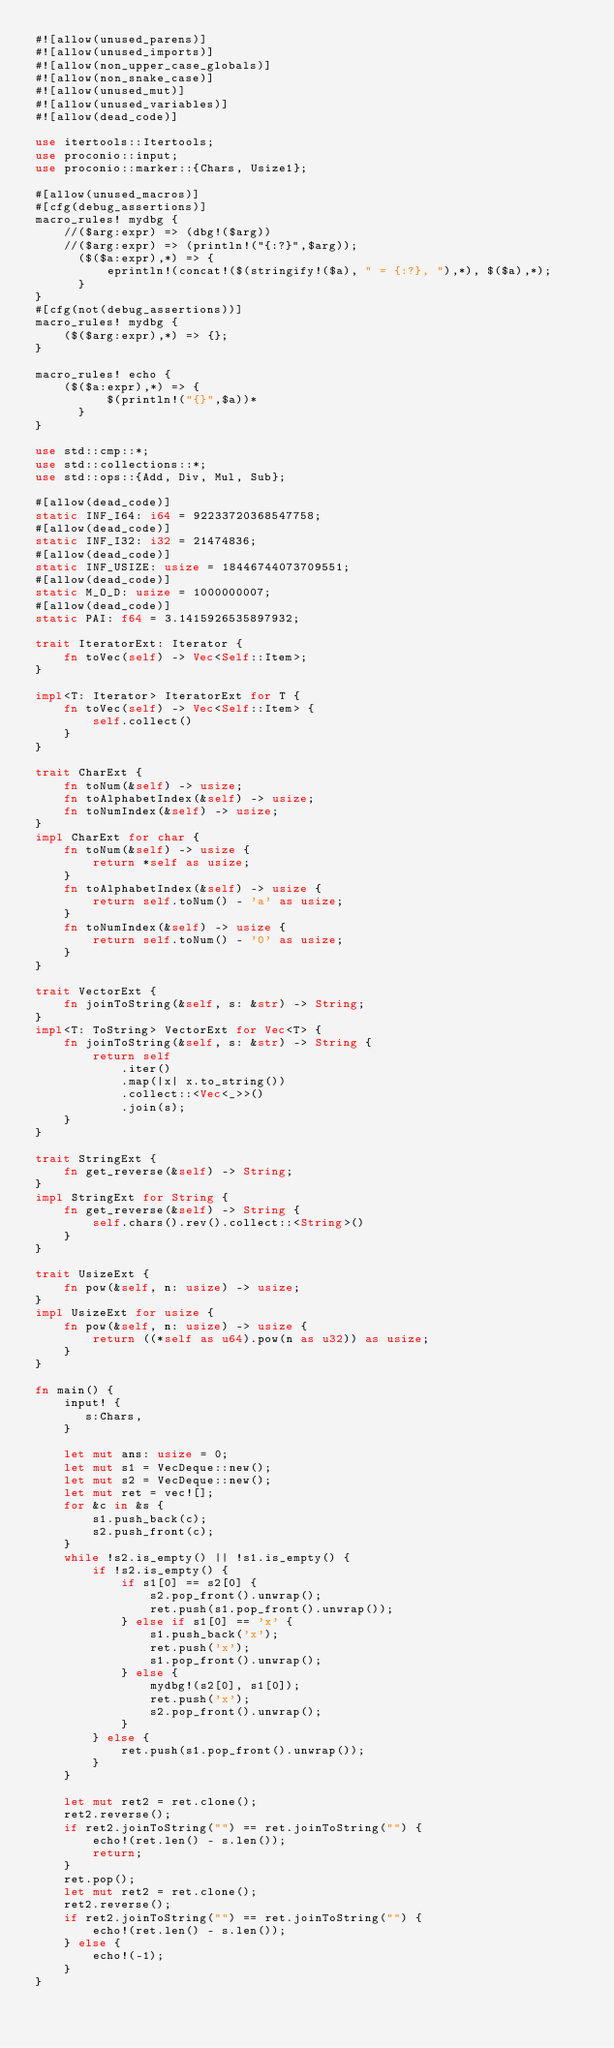<code> <loc_0><loc_0><loc_500><loc_500><_Rust_>#![allow(unused_parens)]
#![allow(unused_imports)]
#![allow(non_upper_case_globals)]
#![allow(non_snake_case)]
#![allow(unused_mut)]
#![allow(unused_variables)]
#![allow(dead_code)]

use itertools::Itertools;
use proconio::input;
use proconio::marker::{Chars, Usize1};

#[allow(unused_macros)]
#[cfg(debug_assertions)]
macro_rules! mydbg {
    //($arg:expr) => (dbg!($arg))
    //($arg:expr) => (println!("{:?}",$arg));
      ($($a:expr),*) => {
          eprintln!(concat!($(stringify!($a), " = {:?}, "),*), $($a),*);
      }
}
#[cfg(not(debug_assertions))]
macro_rules! mydbg {
    ($($arg:expr),*) => {};
}

macro_rules! echo {
    ($($a:expr),*) => {
          $(println!("{}",$a))*
      }
}

use std::cmp::*;
use std::collections::*;
use std::ops::{Add, Div, Mul, Sub};

#[allow(dead_code)]
static INF_I64: i64 = 92233720368547758;
#[allow(dead_code)]
static INF_I32: i32 = 21474836;
#[allow(dead_code)]
static INF_USIZE: usize = 18446744073709551;
#[allow(dead_code)]
static M_O_D: usize = 1000000007;
#[allow(dead_code)]
static PAI: f64 = 3.1415926535897932;

trait IteratorExt: Iterator {
    fn toVec(self) -> Vec<Self::Item>;
}

impl<T: Iterator> IteratorExt for T {
    fn toVec(self) -> Vec<Self::Item> {
        self.collect()
    }
}

trait CharExt {
    fn toNum(&self) -> usize;
    fn toAlphabetIndex(&self) -> usize;
    fn toNumIndex(&self) -> usize;
}
impl CharExt for char {
    fn toNum(&self) -> usize {
        return *self as usize;
    }
    fn toAlphabetIndex(&self) -> usize {
        return self.toNum() - 'a' as usize;
    }
    fn toNumIndex(&self) -> usize {
        return self.toNum() - '0' as usize;
    }
}

trait VectorExt {
    fn joinToString(&self, s: &str) -> String;
}
impl<T: ToString> VectorExt for Vec<T> {
    fn joinToString(&self, s: &str) -> String {
        return self
            .iter()
            .map(|x| x.to_string())
            .collect::<Vec<_>>()
            .join(s);
    }
}

trait StringExt {
    fn get_reverse(&self) -> String;
}
impl StringExt for String {
    fn get_reverse(&self) -> String {
        self.chars().rev().collect::<String>()
    }
}

trait UsizeExt {
    fn pow(&self, n: usize) -> usize;
}
impl UsizeExt for usize {
    fn pow(&self, n: usize) -> usize {
        return ((*self as u64).pow(n as u32)) as usize;
    }
}

fn main() {
    input! {
       s:Chars,
    }

    let mut ans: usize = 0;
    let mut s1 = VecDeque::new();
    let mut s2 = VecDeque::new();
    let mut ret = vec![];
    for &c in &s {
        s1.push_back(c);
        s2.push_front(c);
    }
    while !s2.is_empty() || !s1.is_empty() {
        if !s2.is_empty() {
            if s1[0] == s2[0] {
                s2.pop_front().unwrap();
                ret.push(s1.pop_front().unwrap());
            } else if s1[0] == 'x' {
                s1.push_back('x');
                ret.push('x');
                s1.pop_front().unwrap();
            } else {
                mydbg!(s2[0], s1[0]);
                ret.push('x');
                s2.pop_front().unwrap();
            }
        } else {
            ret.push(s1.pop_front().unwrap());
        }
    }

    let mut ret2 = ret.clone();
    ret2.reverse();
    if ret2.joinToString("") == ret.joinToString("") {
        echo!(ret.len() - s.len());
        return;
    }
    ret.pop();
    let mut ret2 = ret.clone();
    ret2.reverse();
    if ret2.joinToString("") == ret.joinToString("") {
        echo!(ret.len() - s.len());
    } else {
        echo!(-1);
    }
}
</code> 